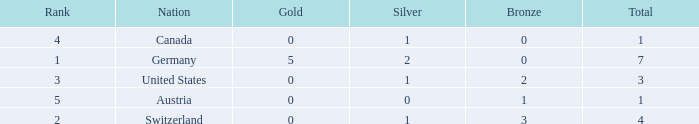What is the full amount of Total for Austria when the number of gold is less than 0? None. 